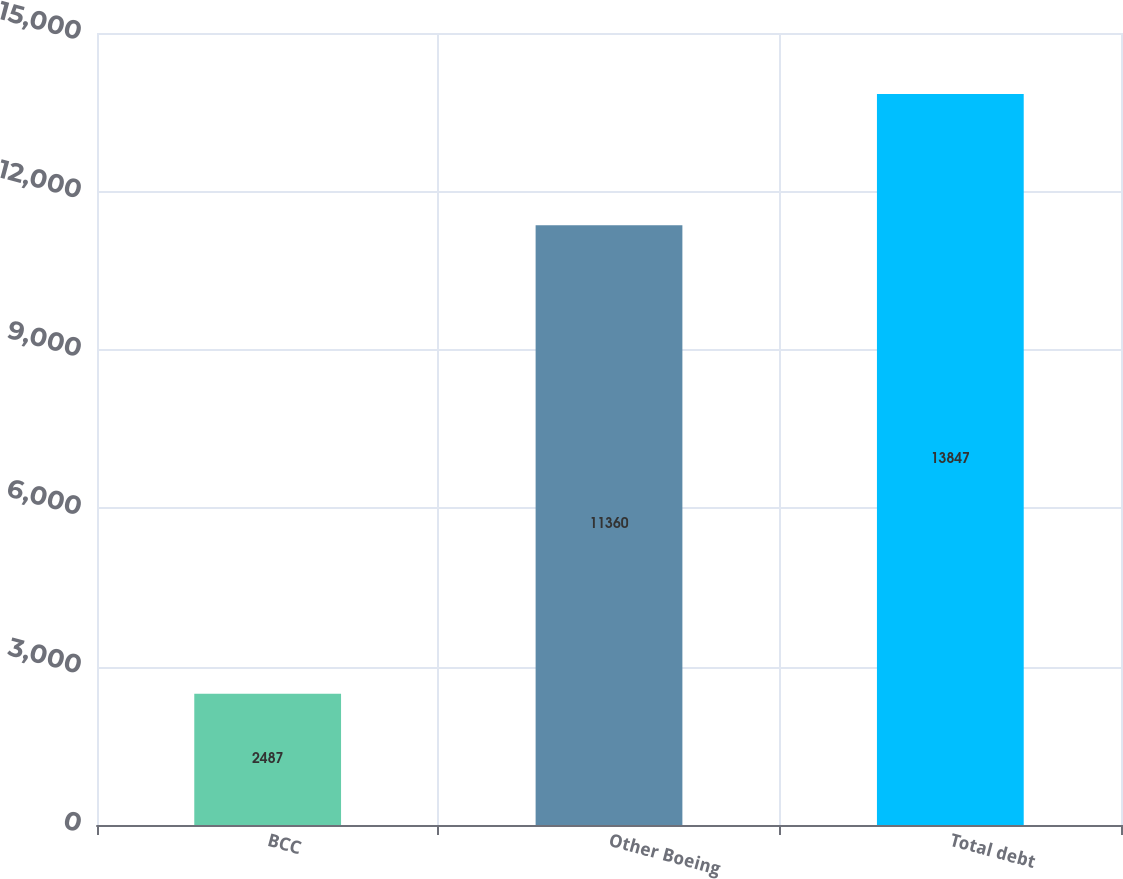Convert chart to OTSL. <chart><loc_0><loc_0><loc_500><loc_500><bar_chart><fcel>BCC<fcel>Other Boeing<fcel>Total debt<nl><fcel>2487<fcel>11360<fcel>13847<nl></chart> 